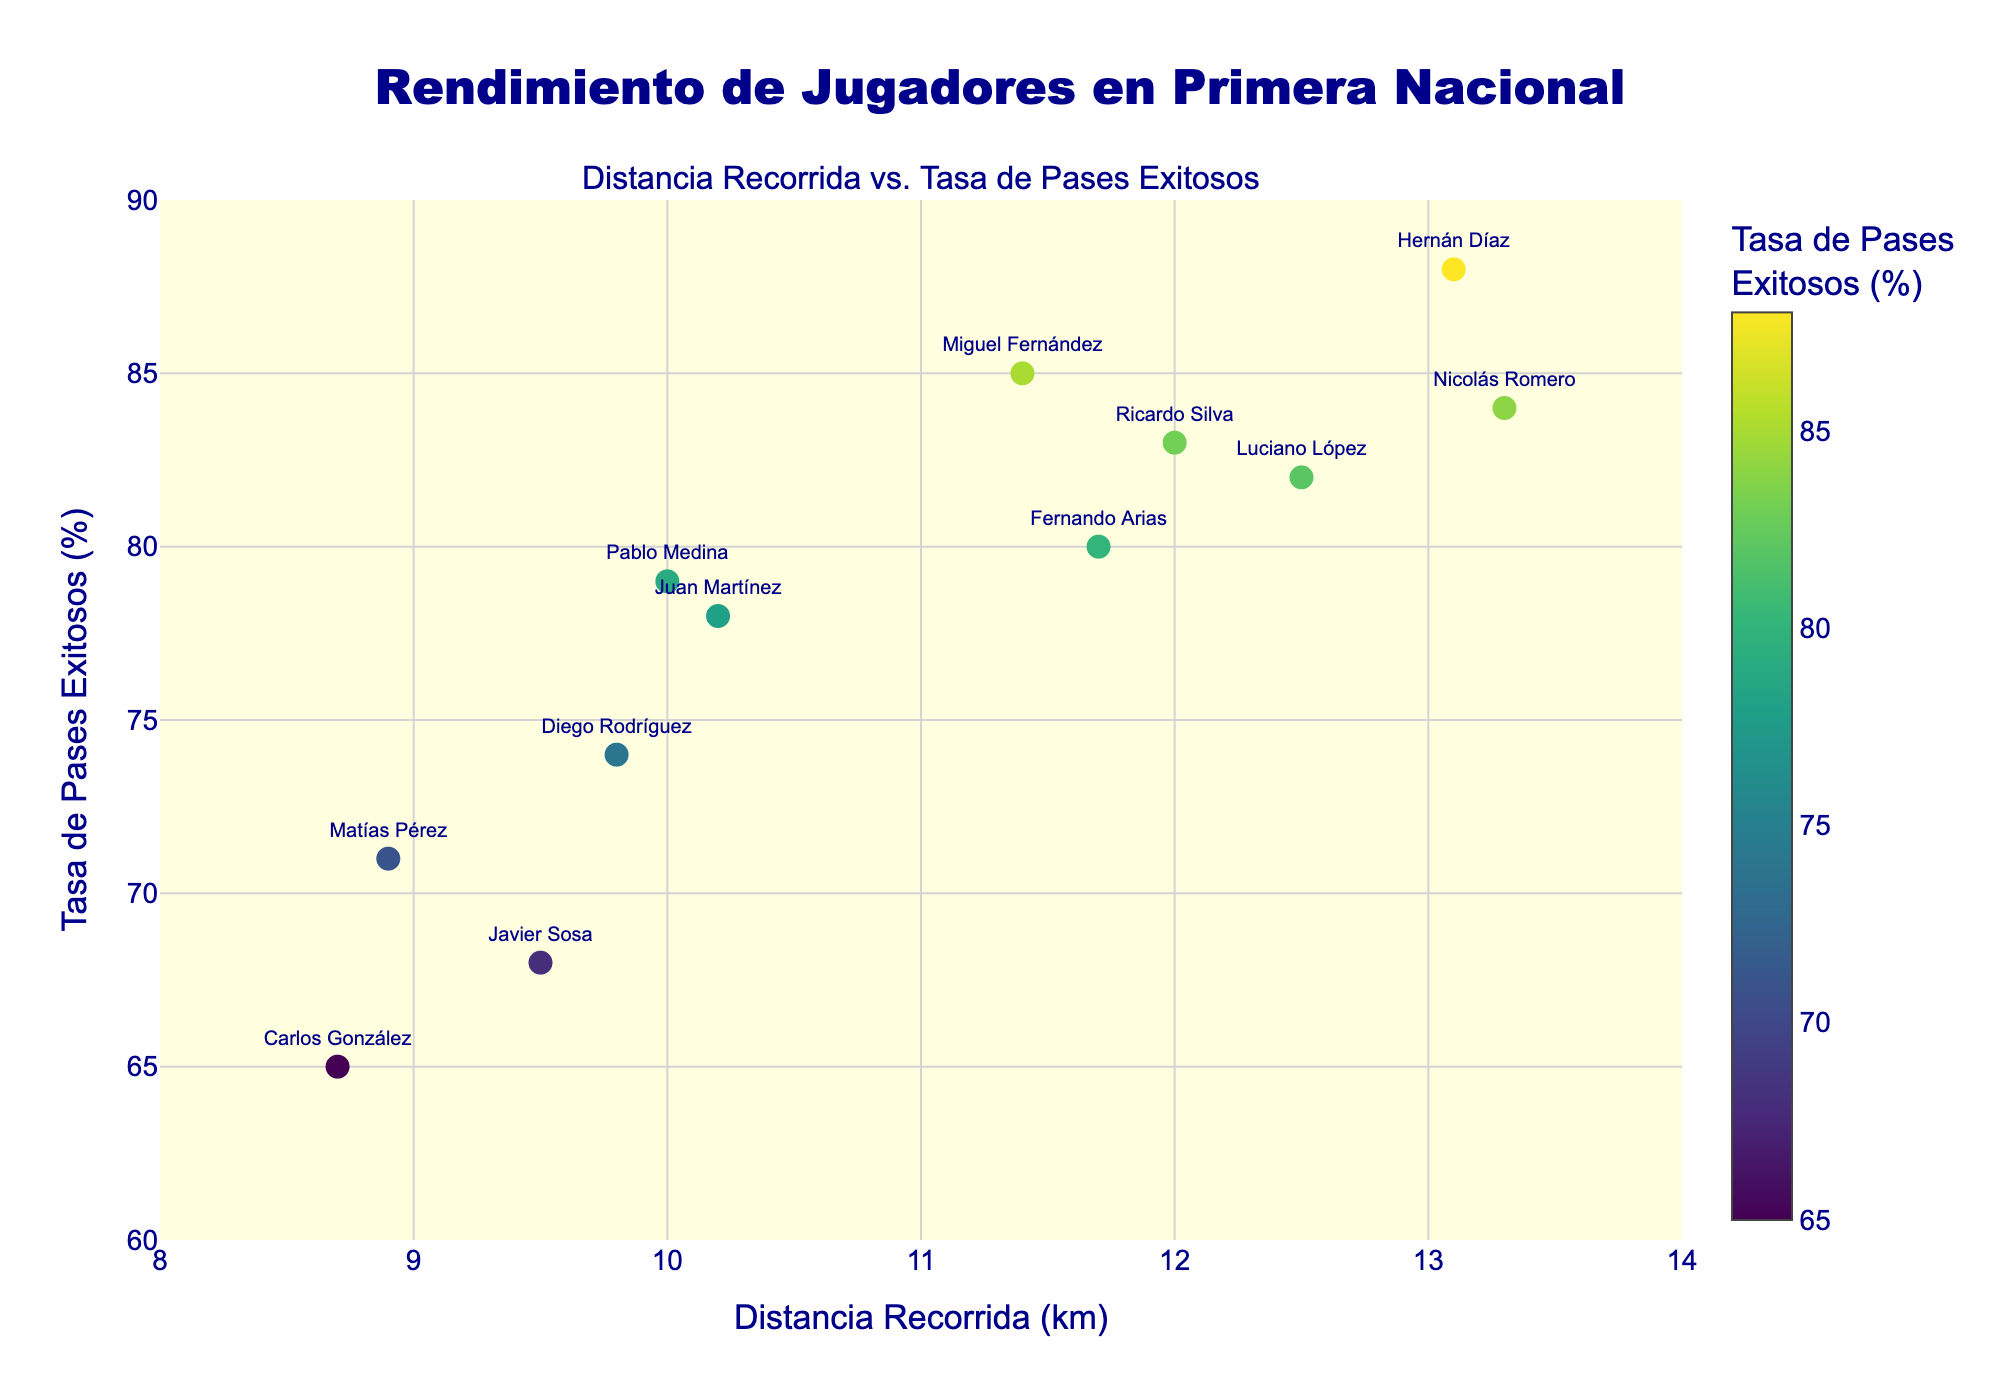What is the title of the figure? The title of the figure is prominently displayed at the top center of the plot. It provides an overview of what the plot represents.
Answer: Rendimiento de Jugadores en Primera Nacional What does the color of the markers represent? The color of the markers represents the Successful Pass Rate Percentage of the players, which is indicated by the color scale on the right.
Answer: Successful Pass Rate Percentage Which player covered the most distance? By looking at the x-axis, which represents the distance covered, the player at the rightmost point on the x-axis covers the most distance.
Answer: Nicolás Romero What is the successful pass rate of Carlos González? To find Carlos González's successful pass rate, look for his name displayed near the marker. The y-axis indicates the successful pass rate.
Answer: 65% Which player has the highest successful pass rate? The player with the highest successful pass rate will be the one located at the highest point on the y-axis.
Answer: Hernán Díaz How does the distance covered by Fernando Arias compare to that of Ricardo Silva? Check their positions along the x-axis to compare their distances. Fernando Arias is positioned slightly to the right of Ricardo Silva.
Answer: Fernando Arias covered more distance What is the average successful pass rate of players who covered more than 12 km? Identify the players who covered more than 12 km on the x-axis and then calculate the average of their successful pass rates.
Answer: (82 + 88 + 84) / 3 = 84.67% Are there any players with a pass rate below 70%? Look at the y-axis to identify markers below 70% and check their associated players.
Answer: Yes, Carlos González and Javier Sosa What is the range of the successful pass rate on the plot? The range can be determined by looking at the maximum and minimum values on the y-axis.
Answer: 65% to 88% Which player has both a high pass rate and covered a substantial distance? Look for players located in the upper right section of the plot. Nicolás Romero and Hernán Díaz meet both criteria.
Answer: Nicolás Romero or Hernán Díaz 